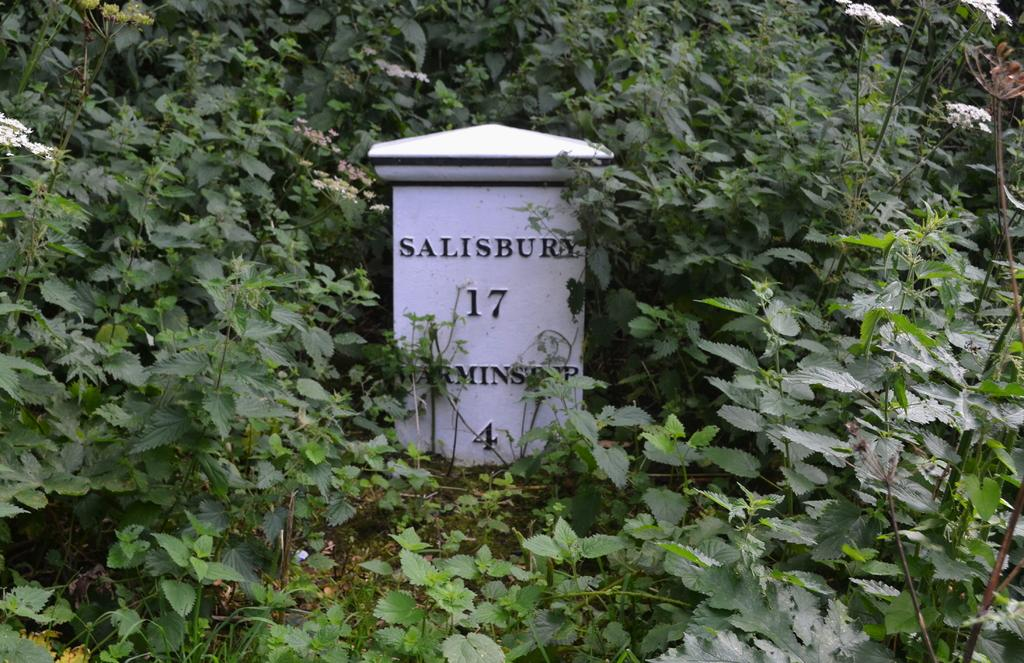What is the primary subject of the image? The primary subject of the image is the many plants. Can you describe any additional features in the image? Yes, there is text on a stone in the image. What route should be taken to reach the idea mentioned in the image? There is no route or idea mentioned in the image; it primarily features plants and text on a stone. 